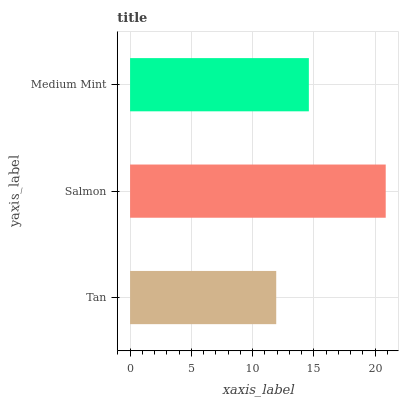Is Tan the minimum?
Answer yes or no. Yes. Is Salmon the maximum?
Answer yes or no. Yes. Is Medium Mint the minimum?
Answer yes or no. No. Is Medium Mint the maximum?
Answer yes or no. No. Is Salmon greater than Medium Mint?
Answer yes or no. Yes. Is Medium Mint less than Salmon?
Answer yes or no. Yes. Is Medium Mint greater than Salmon?
Answer yes or no. No. Is Salmon less than Medium Mint?
Answer yes or no. No. Is Medium Mint the high median?
Answer yes or no. Yes. Is Medium Mint the low median?
Answer yes or no. Yes. Is Salmon the high median?
Answer yes or no. No. Is Salmon the low median?
Answer yes or no. No. 